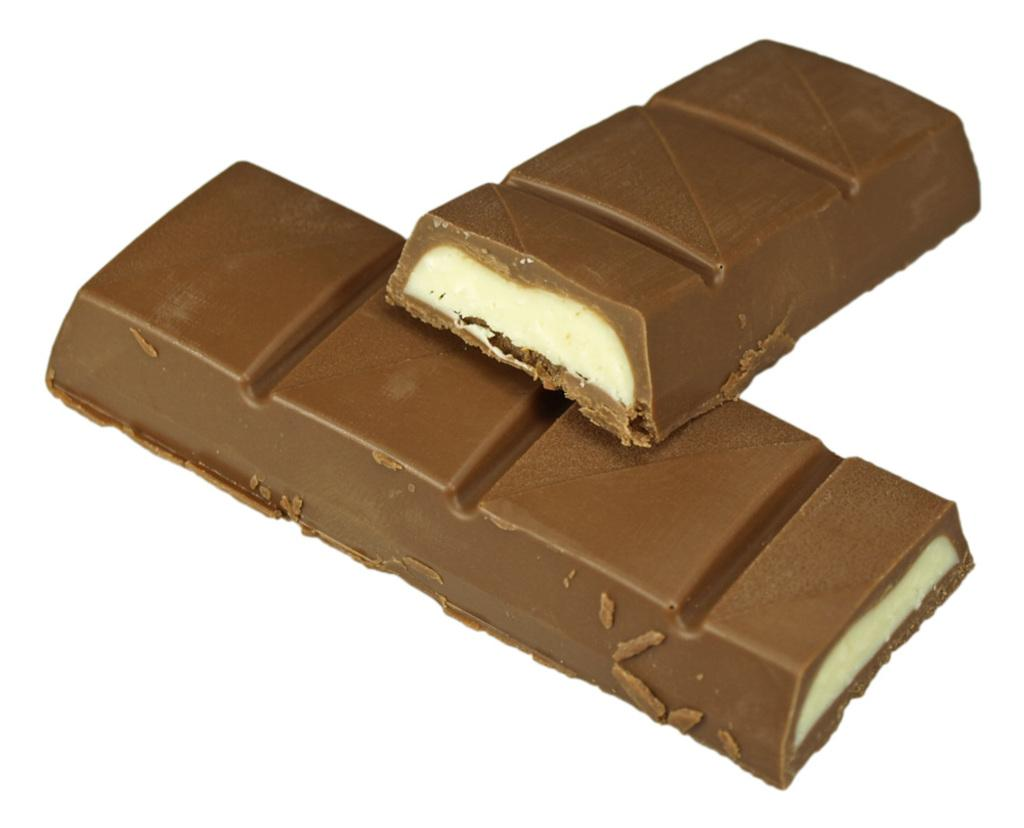What type of food is shown in the image? There are two bites of caramel chocolates in the image. How are the bites of caramel chocolates positioned in the image? One bite is above the other. What type of railway is depicted in the image? There is no railway present in the image; it features two bites of caramel chocolates. What role does the notebook play in the image? There is no notebook present in the image. 